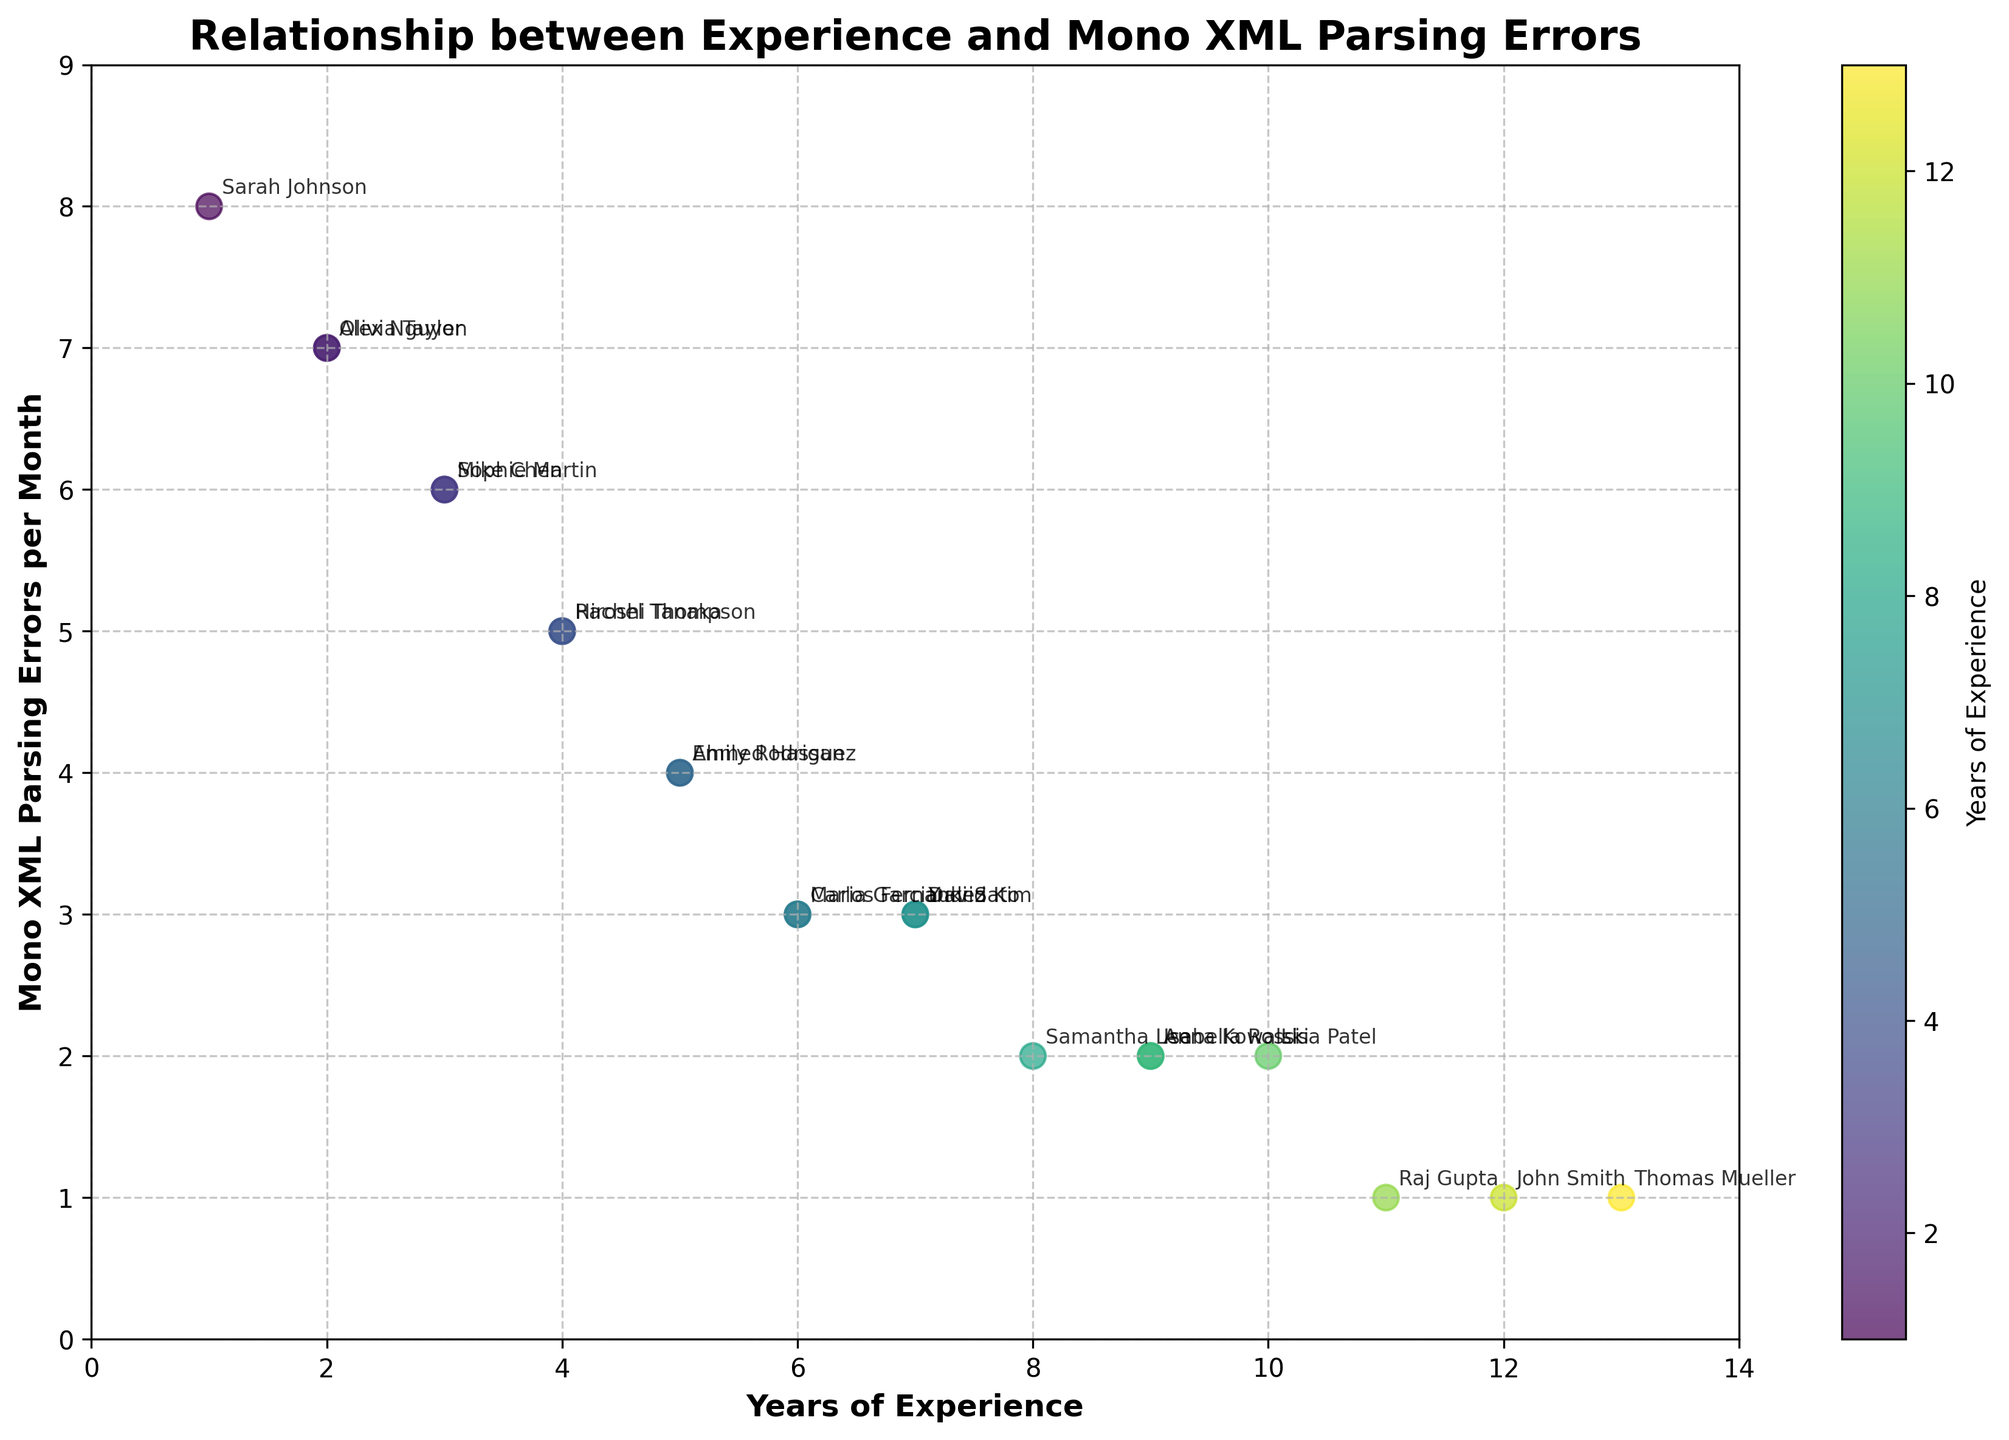What is the title of the figure? The title is located at the top of the figure, displaying the main topic or the purpose of the plot.
Answer: Relationship between Experience and Mono XML Parsing Errors How is the color of the data points determined in the figure? The color of the points represents the years of experience, with darker shades indicating more experience and lighter shades indicating less experience.
Answer: By years of experience Which engineer has the least frequency of Mono XML Parsing errors per month? Locate the point that is lowest on the y-axis and check the annotated name next to it.
Answer: John Smith What can you infer about the general relationship between years of experience and Mono XML parsing errors? By observing the scatter plot, it's apparent that as years of experience increase, the frequency of Mono XML parsing errors decreases.
Answer: Errors decrease with more experience What is the range of Mono XML Parsing errors per month? The range can be identified by the minimum and maximum y-values on the y-axis.
Answer: 1 to 8 How many engineers have a monthly Mono XML Parsing error frequency of 3? Count the number of points horizontally aligned at y = 3.
Answer: 4 Compare the number of parsing errors between an engineer with 5 years of experience and an engineer with 10 years of experience. Identify the relevant points and compare their y-values: 5 years (4 errors) vs. 10 years (2 errors).
Answer: 2 less for 10 years of experience Which data points indicate engineers with 2 years of experience? Locate the points at x = 2 and note their y-values and associated names through annotation.
Answer: Alex Nguyen, Olivia Taylor What is the mean frequency of Mono XML Parsing errors across all the engineers? Sum the y-values for all points and divide by the total number of engineers (20). (8 + 6 + 4 + 3 + 2 + 7 + 5 + 3 + 2 + 1 + 2 + 1 + 7 + 5 + 3 + 1 + 6 + 4 + 3 + 2) = 75. Mean = 75 / 20.
Answer: 3.75 Which engineer with over 10 years of experience has the least number of parsing errors, and how many errors do they encounter per month? Find the points beyond x = 10 and compare their y-values.
Answer: John Smith and Raj Gupta, 1 each 